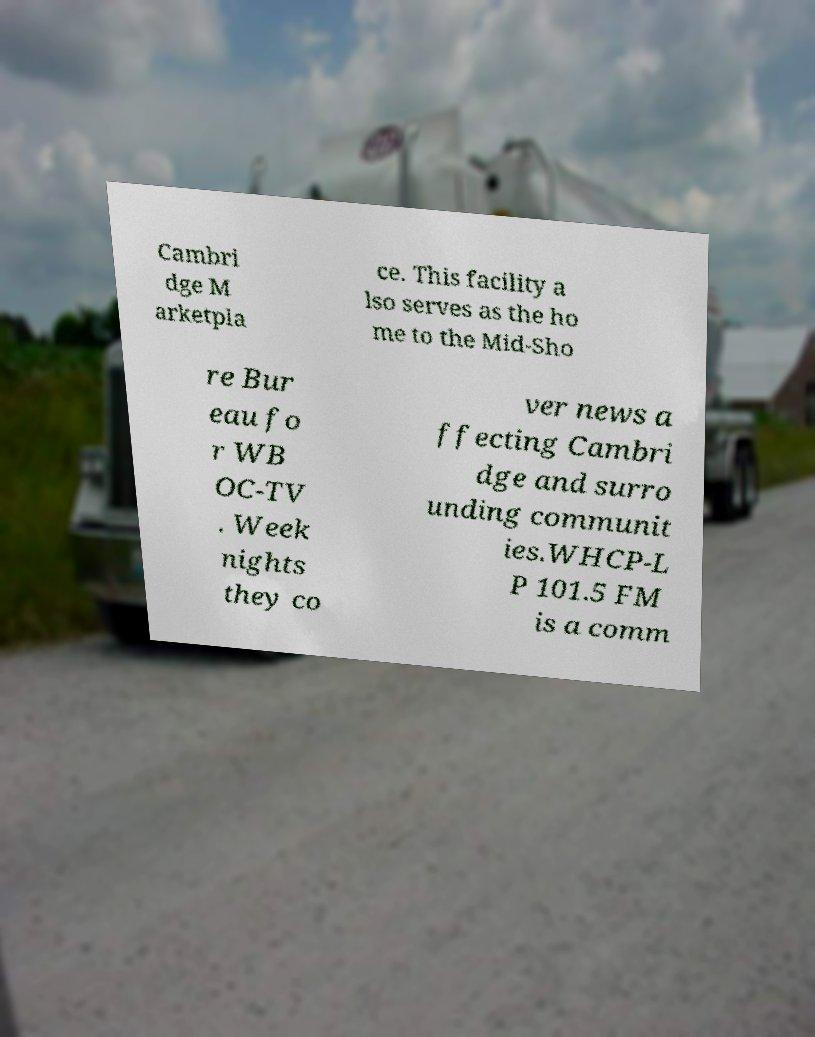What messages or text are displayed in this image? I need them in a readable, typed format. Cambri dge M arketpla ce. This facility a lso serves as the ho me to the Mid-Sho re Bur eau fo r WB OC-TV . Week nights they co ver news a ffecting Cambri dge and surro unding communit ies.WHCP-L P 101.5 FM is a comm 